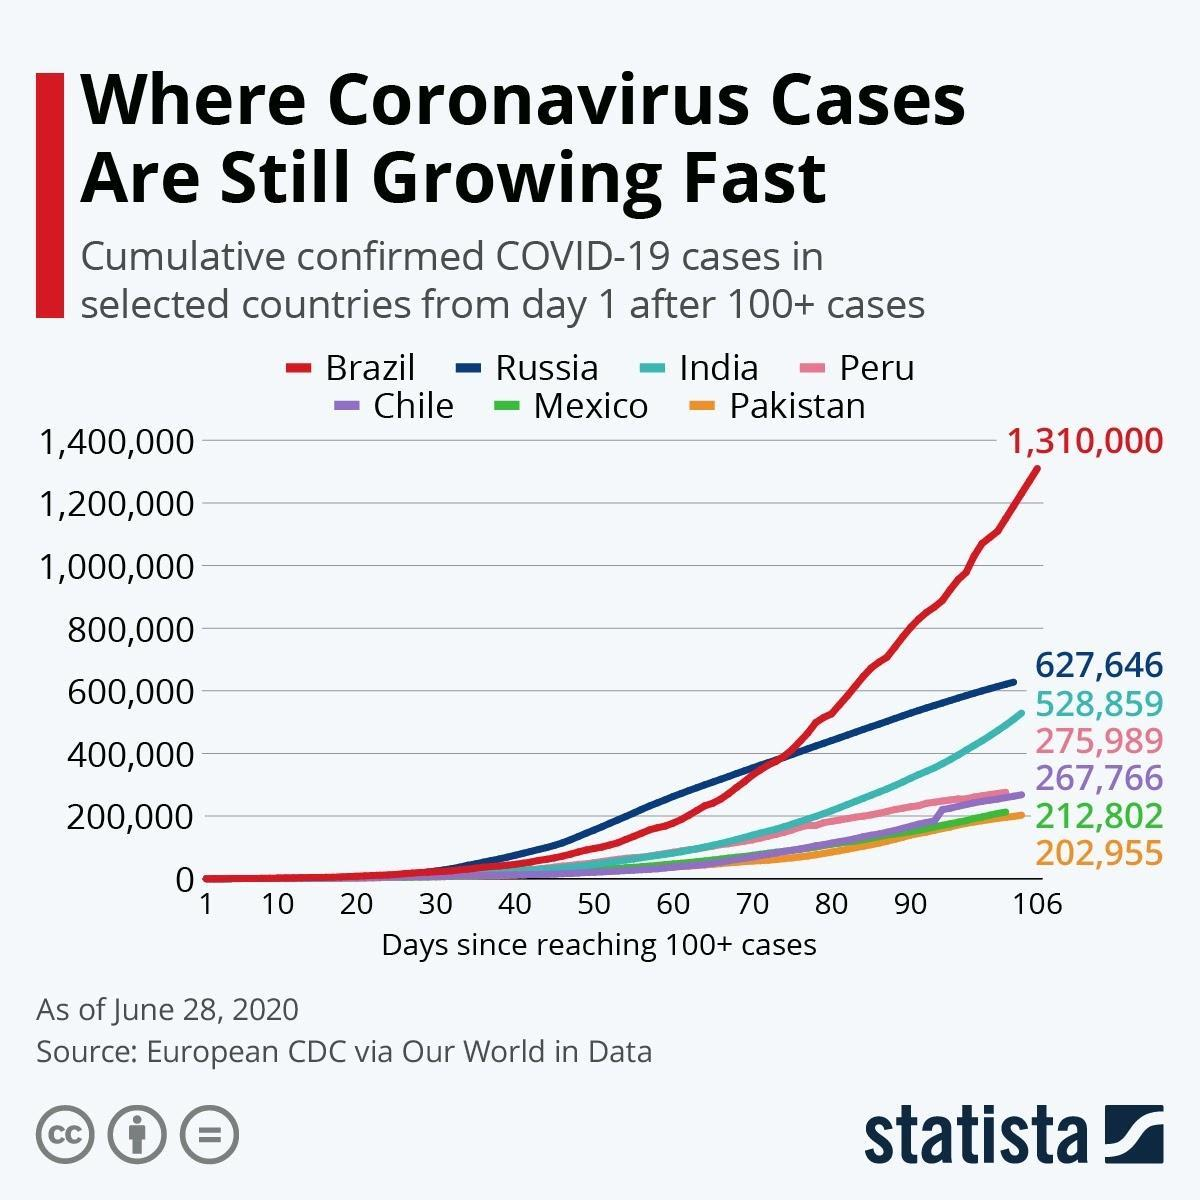Which country has reported the second least number of confirmed COVID-19 cases among the selected countries as of June 28, 2020?
Answer the question with a short phrase. Mexico Which country has reported the second highest number of confirmed COVID-19 cases among the selected countries as of June 28, 2020? Russia Which country has reported the least number of confirmed COVID-19 cases among the selected countries as of June 28, 2020? Pakistan What is the cumulative number of confirmed COVID-19 cases in Peru as of June 28, 2020? 275,989 Which country has reported the highest number of confirmed COVID-19 cases among the selected countries as of June 28, 2020? Brazil What is the cumulative number of confirmed COVID-19 cases in Brazil as of June 28, 2020? 1,310,000 What is the cumulative number of confirmed COVID-19 cases in Chile as of June 28, 2020? 267,766 What is the cumulative number of confirmed COVID-19 cases in Mexico as of June 28, 2020? 212,802 What is the cumulative number of confirmed COVID-19 cases in India as of June 28, 2020? 528,859 